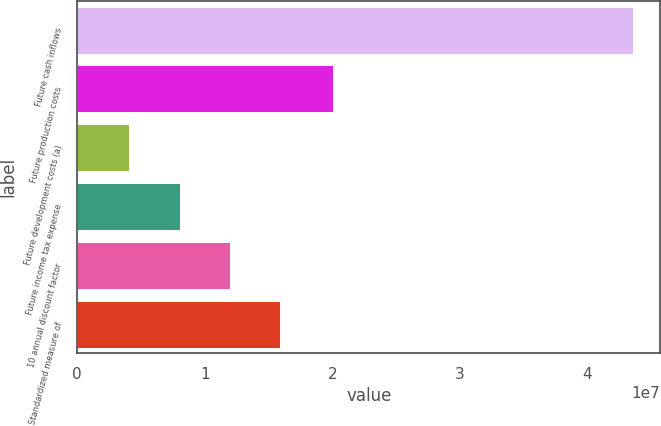Convert chart to OTSL. <chart><loc_0><loc_0><loc_500><loc_500><bar_chart><fcel>Future cash inflows<fcel>Future production costs<fcel>Future development costs (a)<fcel>Future income tax expense<fcel>10 annual discount factor<fcel>Standardized measure of<nl><fcel>4.3542e+07<fcel>2.00441e+07<fcel>4.1018e+06<fcel>8.04582e+06<fcel>1.19898e+07<fcel>1.59339e+07<nl></chart> 